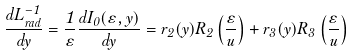Convert formula to latex. <formula><loc_0><loc_0><loc_500><loc_500>\frac { d L _ { r a d } ^ { - 1 } } { d y } = \frac { 1 } { \varepsilon } \frac { d I _ { 0 } ( \varepsilon , y ) } { d y } = r _ { 2 } ( y ) R _ { 2 } \left ( \frac { \varepsilon } { u } \right ) + r _ { 3 } ( y ) R _ { 3 } \left ( \frac { \varepsilon } { u } \right )</formula> 